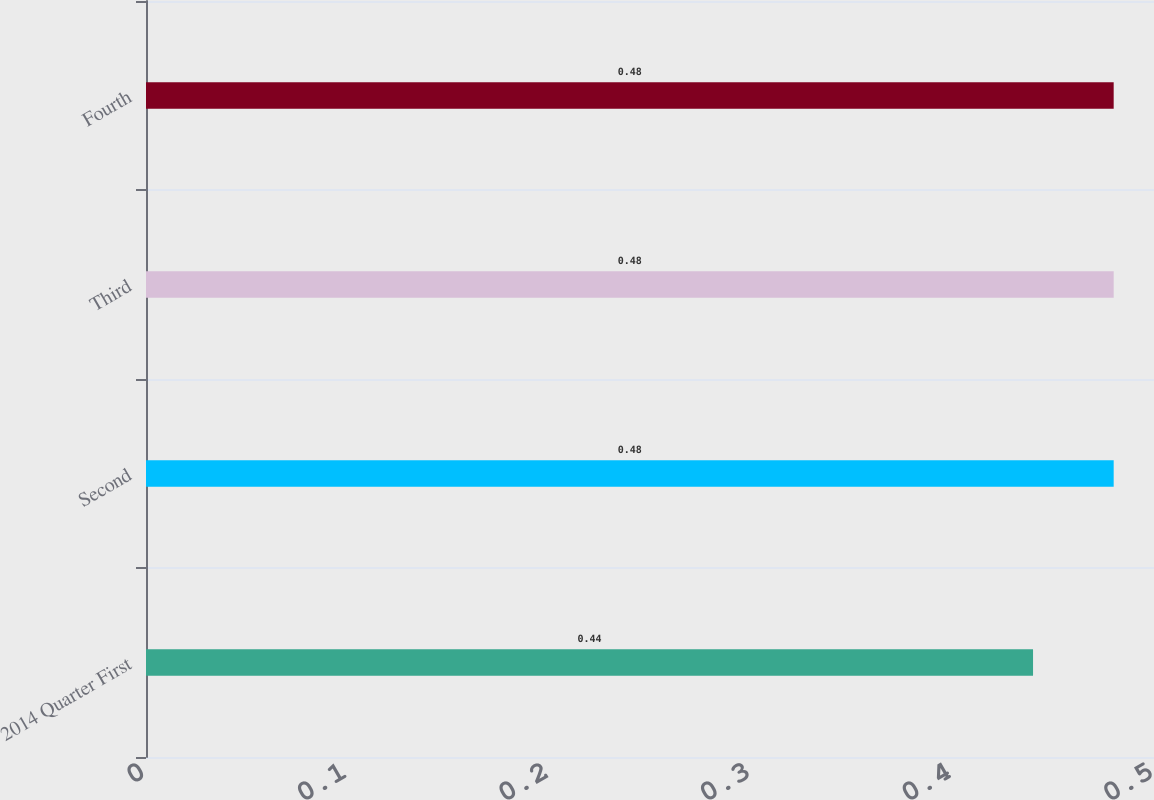Convert chart. <chart><loc_0><loc_0><loc_500><loc_500><bar_chart><fcel>2014 Quarter First<fcel>Second<fcel>Third<fcel>Fourth<nl><fcel>0.44<fcel>0.48<fcel>0.48<fcel>0.48<nl></chart> 